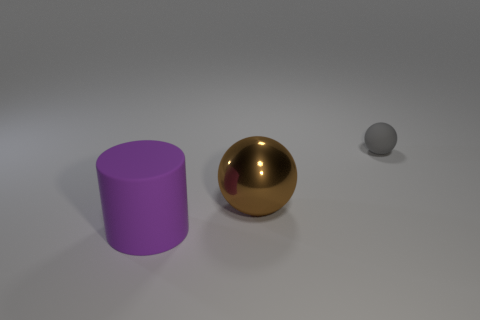Can you describe the colors of the objects shown in the image? Certainly, there are three objects, each with a distinct color. There's a violet cylinder, a golden sphere, and a small grey sphere. 